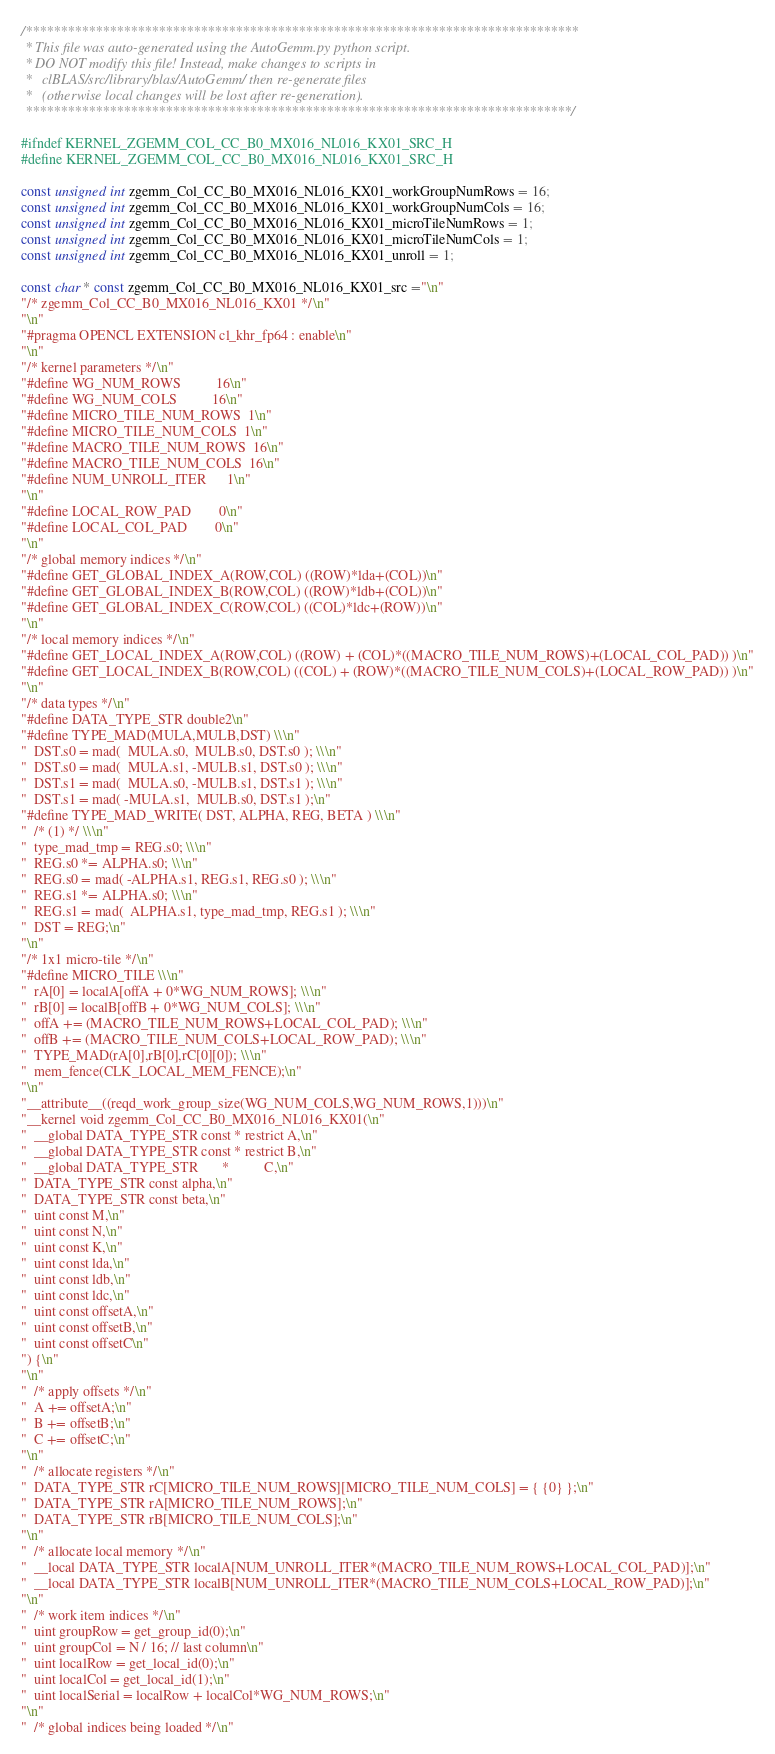Convert code to text. <code><loc_0><loc_0><loc_500><loc_500><_C++_>/*******************************************************************************
 * This file was auto-generated using the AutoGemm.py python script.
 * DO NOT modify this file! Instead, make changes to scripts in
 *   clBLAS/src/library/blas/AutoGemm/ then re-generate files
 *   (otherwise local changes will be lost after re-generation).
 ******************************************************************************/

#ifndef KERNEL_ZGEMM_COL_CC_B0_MX016_NL016_KX01_SRC_H
#define KERNEL_ZGEMM_COL_CC_B0_MX016_NL016_KX01_SRC_H

const unsigned int zgemm_Col_CC_B0_MX016_NL016_KX01_workGroupNumRows = 16;
const unsigned int zgemm_Col_CC_B0_MX016_NL016_KX01_workGroupNumCols = 16;
const unsigned int zgemm_Col_CC_B0_MX016_NL016_KX01_microTileNumRows = 1;
const unsigned int zgemm_Col_CC_B0_MX016_NL016_KX01_microTileNumCols = 1;
const unsigned int zgemm_Col_CC_B0_MX016_NL016_KX01_unroll = 1;

const char * const zgemm_Col_CC_B0_MX016_NL016_KX01_src ="\n"
"/* zgemm_Col_CC_B0_MX016_NL016_KX01 */\n"
"\n"
"#pragma OPENCL EXTENSION cl_khr_fp64 : enable\n"
"\n"
"/* kernel parameters */\n"
"#define WG_NUM_ROWS          16\n"
"#define WG_NUM_COLS          16\n"
"#define MICRO_TILE_NUM_ROWS  1\n"
"#define MICRO_TILE_NUM_COLS  1\n"
"#define MACRO_TILE_NUM_ROWS  16\n"
"#define MACRO_TILE_NUM_COLS  16\n"
"#define NUM_UNROLL_ITER      1\n"
"\n"
"#define LOCAL_ROW_PAD        0\n"
"#define LOCAL_COL_PAD        0\n"
"\n"
"/* global memory indices */\n"
"#define GET_GLOBAL_INDEX_A(ROW,COL) ((ROW)*lda+(COL))\n"
"#define GET_GLOBAL_INDEX_B(ROW,COL) ((ROW)*ldb+(COL))\n"
"#define GET_GLOBAL_INDEX_C(ROW,COL) ((COL)*ldc+(ROW))\n"
"\n"
"/* local memory indices */\n"
"#define GET_LOCAL_INDEX_A(ROW,COL) ((ROW) + (COL)*((MACRO_TILE_NUM_ROWS)+(LOCAL_COL_PAD)) )\n"
"#define GET_LOCAL_INDEX_B(ROW,COL) ((COL) + (ROW)*((MACRO_TILE_NUM_COLS)+(LOCAL_ROW_PAD)) )\n"
"\n"
"/* data types */\n"
"#define DATA_TYPE_STR double2\n"
"#define TYPE_MAD(MULA,MULB,DST) \\\n"
"  DST.s0 = mad(  MULA.s0,  MULB.s0, DST.s0 ); \\\n"
"  DST.s0 = mad(  MULA.s1, -MULB.s1, DST.s0 ); \\\n"
"  DST.s1 = mad(  MULA.s0, -MULB.s1, DST.s1 ); \\\n"
"  DST.s1 = mad( -MULA.s1,  MULB.s0, DST.s1 );\n"
"#define TYPE_MAD_WRITE( DST, ALPHA, REG, BETA ) \\\n"
"  /* (1) */ \\\n"
"  type_mad_tmp = REG.s0; \\\n"
"  REG.s0 *= ALPHA.s0; \\\n"
"  REG.s0 = mad( -ALPHA.s1, REG.s1, REG.s0 ); \\\n"
"  REG.s1 *= ALPHA.s0; \\\n"
"  REG.s1 = mad(  ALPHA.s1, type_mad_tmp, REG.s1 ); \\\n"
"  DST = REG;\n"
"\n"
"/* 1x1 micro-tile */\n"
"#define MICRO_TILE \\\n"
"  rA[0] = localA[offA + 0*WG_NUM_ROWS]; \\\n"
"  rB[0] = localB[offB + 0*WG_NUM_COLS]; \\\n"
"  offA += (MACRO_TILE_NUM_ROWS+LOCAL_COL_PAD); \\\n"
"  offB += (MACRO_TILE_NUM_COLS+LOCAL_ROW_PAD); \\\n"
"  TYPE_MAD(rA[0],rB[0],rC[0][0]); \\\n"
"  mem_fence(CLK_LOCAL_MEM_FENCE);\n"
"\n"
"__attribute__((reqd_work_group_size(WG_NUM_COLS,WG_NUM_ROWS,1)))\n"
"__kernel void zgemm_Col_CC_B0_MX016_NL016_KX01(\n"
"  __global DATA_TYPE_STR const * restrict A,\n"
"  __global DATA_TYPE_STR const * restrict B,\n"
"  __global DATA_TYPE_STR       *          C,\n"
"  DATA_TYPE_STR const alpha,\n"
"  DATA_TYPE_STR const beta,\n"
"  uint const M,\n"
"  uint const N,\n"
"  uint const K,\n"
"  uint const lda,\n"
"  uint const ldb,\n"
"  uint const ldc,\n"
"  uint const offsetA,\n"
"  uint const offsetB,\n"
"  uint const offsetC\n"
") {\n"
"\n"
"  /* apply offsets */\n"
"  A += offsetA;\n"
"  B += offsetB;\n"
"  C += offsetC;\n"
"\n"
"  /* allocate registers */\n"
"  DATA_TYPE_STR rC[MICRO_TILE_NUM_ROWS][MICRO_TILE_NUM_COLS] = { {0} };\n"
"  DATA_TYPE_STR rA[MICRO_TILE_NUM_ROWS];\n"
"  DATA_TYPE_STR rB[MICRO_TILE_NUM_COLS];\n"
"\n"
"  /* allocate local memory */\n"
"  __local DATA_TYPE_STR localA[NUM_UNROLL_ITER*(MACRO_TILE_NUM_ROWS+LOCAL_COL_PAD)];\n"
"  __local DATA_TYPE_STR localB[NUM_UNROLL_ITER*(MACRO_TILE_NUM_COLS+LOCAL_ROW_PAD)];\n"
"\n"
"  /* work item indices */\n"
"  uint groupRow = get_group_id(0);\n"
"  uint groupCol = N / 16; // last column\n"
"  uint localRow = get_local_id(0);\n"
"  uint localCol = get_local_id(1);\n"
"  uint localSerial = localRow + localCol*WG_NUM_ROWS;\n"
"\n"
"  /* global indices being loaded */\n"</code> 